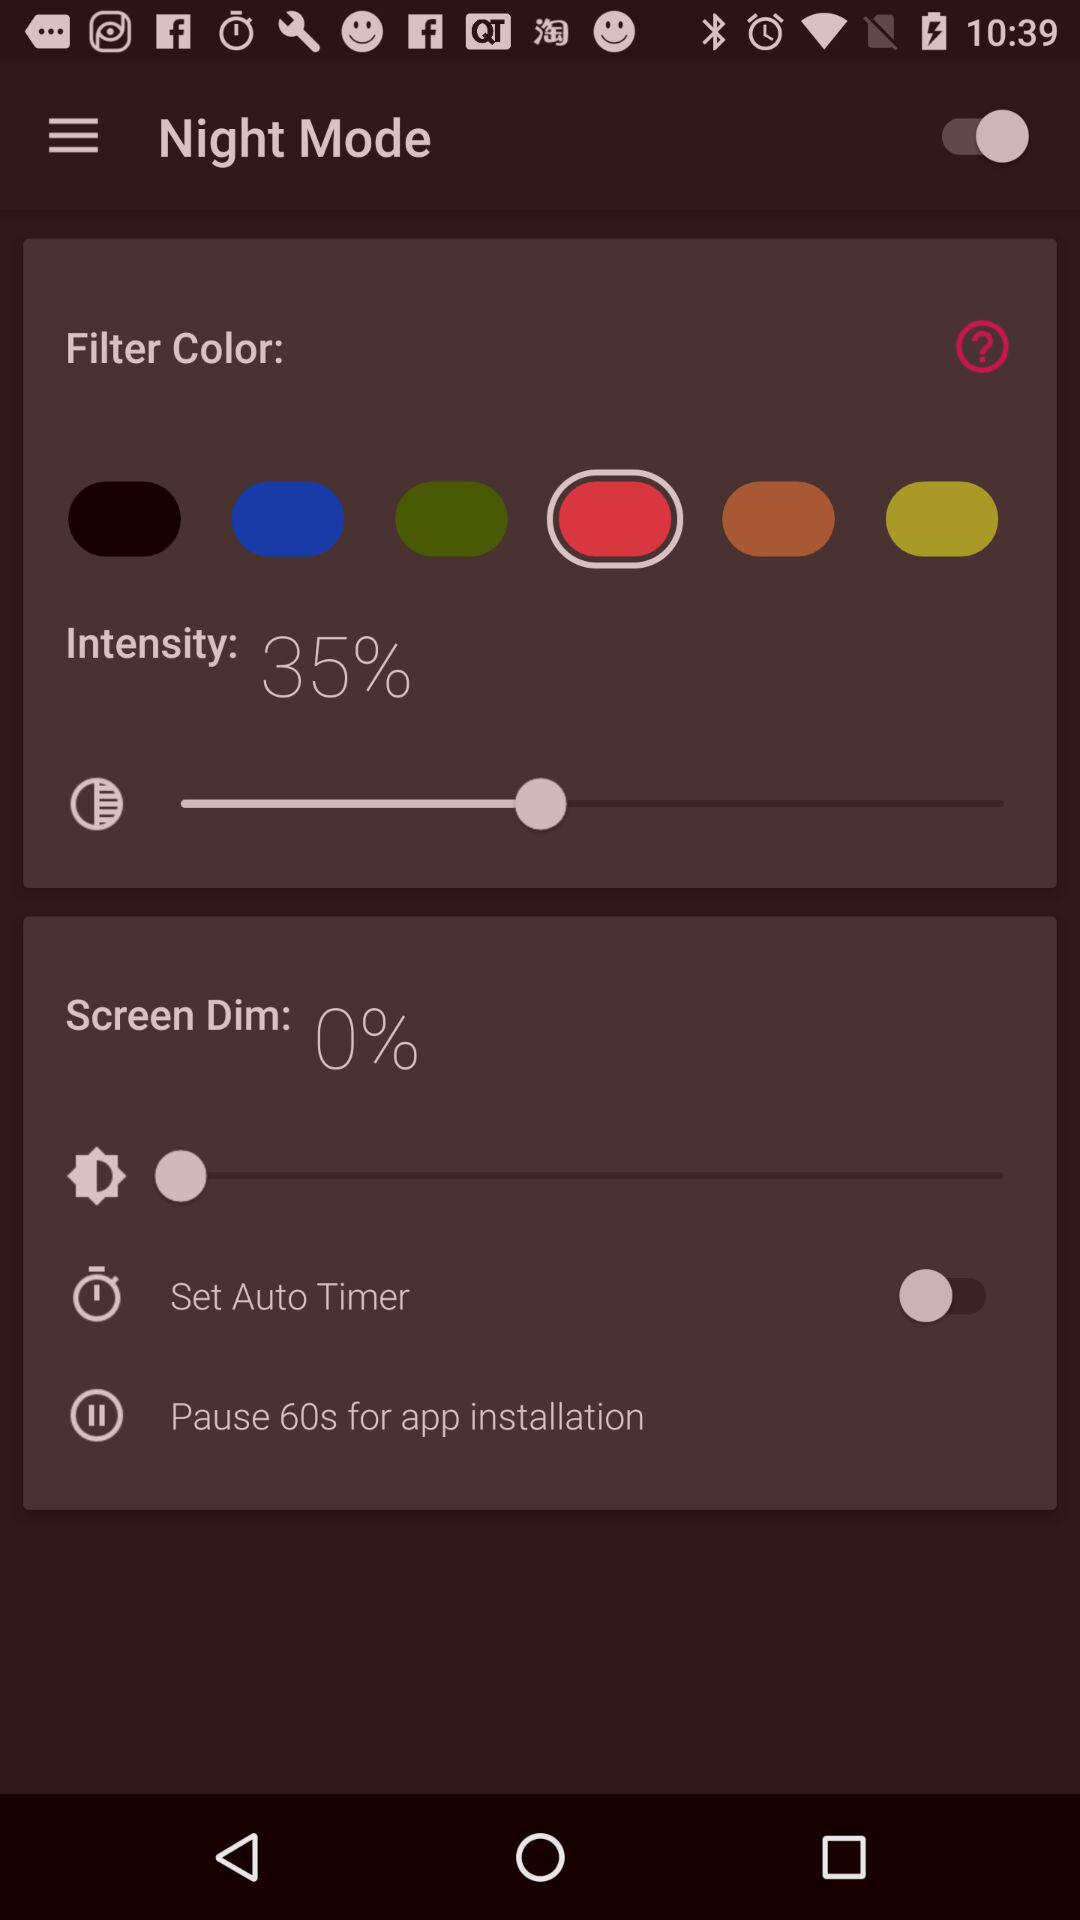For how many seconds can the application installation be paused? The application installation can be paused for 60 seconds. 